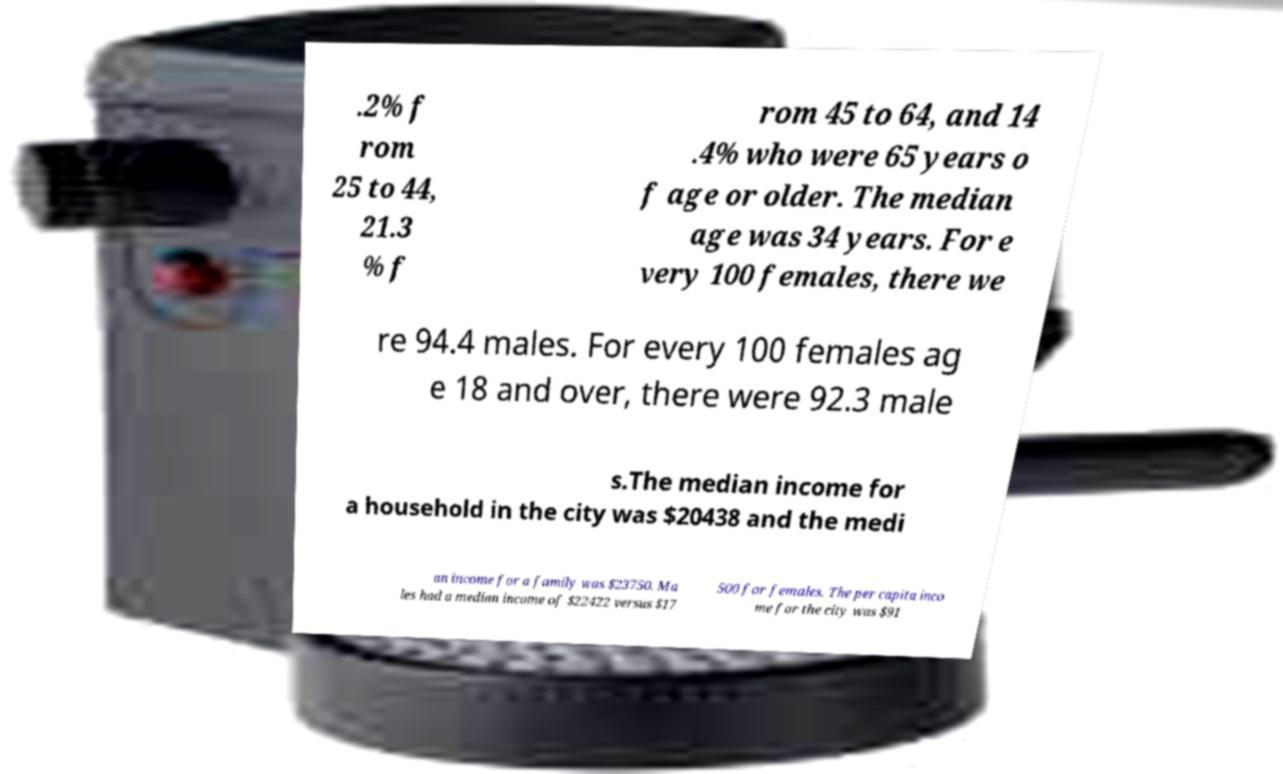There's text embedded in this image that I need extracted. Can you transcribe it verbatim? .2% f rom 25 to 44, 21.3 % f rom 45 to 64, and 14 .4% who were 65 years o f age or older. The median age was 34 years. For e very 100 females, there we re 94.4 males. For every 100 females ag e 18 and over, there were 92.3 male s.The median income for a household in the city was $20438 and the medi an income for a family was $23750. Ma les had a median income of $22422 versus $17 500 for females. The per capita inco me for the city was $91 